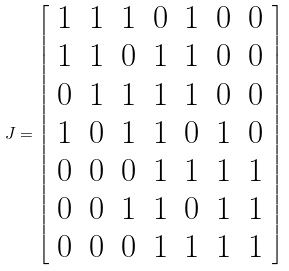Convert formula to latex. <formula><loc_0><loc_0><loc_500><loc_500>J = \left [ \begin{array} { c c c c c c c } 1 & 1 & 1 & 0 & 1 & 0 & 0 \\ 1 & 1 & 0 & 1 & 1 & 0 & 0 \\ 0 & 1 & 1 & 1 & 1 & 0 & 0 \\ 1 & 0 & 1 & 1 & 0 & 1 & 0 \\ 0 & 0 & 0 & 1 & 1 & 1 & 1 \\ 0 & 0 & 1 & 1 & 0 & 1 & 1 \\ 0 & 0 & 0 & 1 & 1 & 1 & 1 \\ \end{array} \right ] \\</formula> 